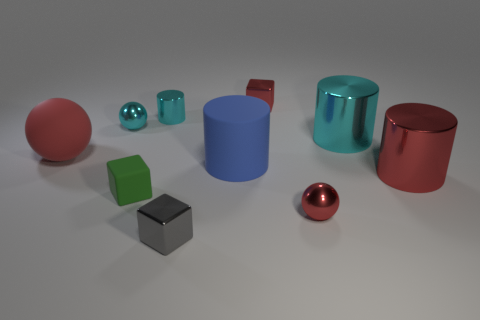What materials do the objects in the image appear to be made of? The objects in the image seem to be made from various materials. The small cube looks metallic, suggesting it could be made of metal, whereas the balls and the cylindrical items exhibit a shiny, smooth texture which can indicate they are made of a plastic or polished rubber material. 